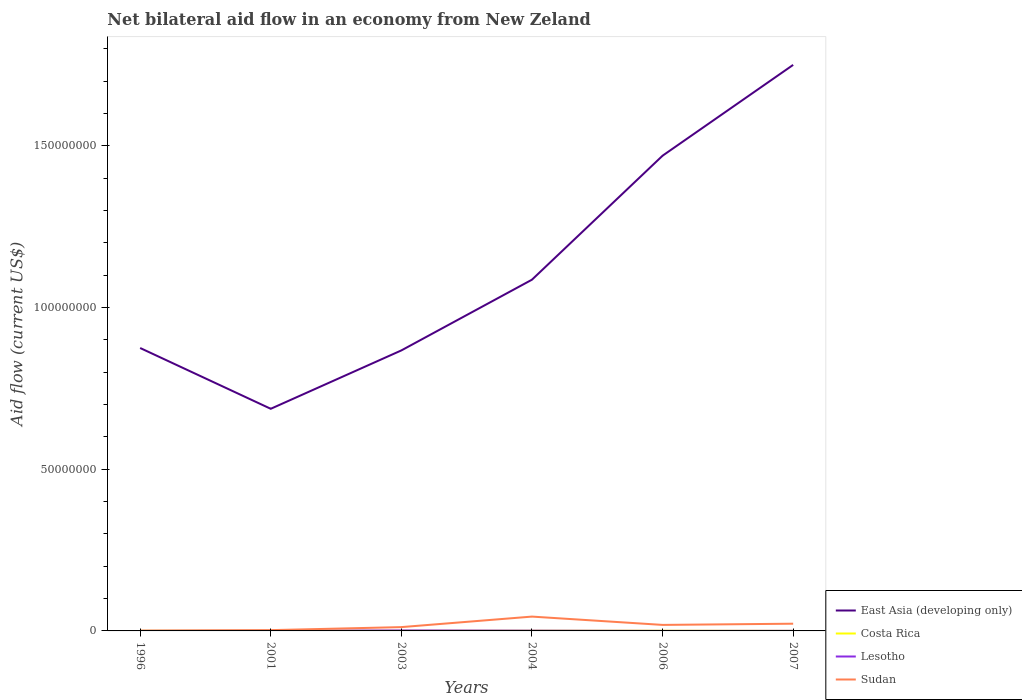Is the number of lines equal to the number of legend labels?
Your answer should be very brief. Yes. In which year was the net bilateral aid flow in East Asia (developing only) maximum?
Provide a short and direct response. 2001. How many years are there in the graph?
Keep it short and to the point. 6. What is the difference between two consecutive major ticks on the Y-axis?
Your response must be concise. 5.00e+07. Does the graph contain any zero values?
Give a very brief answer. No. Does the graph contain grids?
Offer a terse response. No. How are the legend labels stacked?
Your answer should be very brief. Vertical. What is the title of the graph?
Offer a very short reply. Net bilateral aid flow in an economy from New Zeland. Does "Eritrea" appear as one of the legend labels in the graph?
Offer a very short reply. No. What is the label or title of the X-axis?
Give a very brief answer. Years. What is the label or title of the Y-axis?
Your response must be concise. Aid flow (current US$). What is the Aid flow (current US$) of East Asia (developing only) in 1996?
Your answer should be compact. 8.75e+07. What is the Aid flow (current US$) in Costa Rica in 1996?
Your answer should be compact. 4.00e+04. What is the Aid flow (current US$) of Lesotho in 1996?
Ensure brevity in your answer.  10000. What is the Aid flow (current US$) of Sudan in 1996?
Provide a short and direct response. 7.00e+04. What is the Aid flow (current US$) of East Asia (developing only) in 2001?
Ensure brevity in your answer.  6.87e+07. What is the Aid flow (current US$) in Sudan in 2001?
Offer a terse response. 2.40e+05. What is the Aid flow (current US$) in East Asia (developing only) in 2003?
Ensure brevity in your answer.  8.67e+07. What is the Aid flow (current US$) in Lesotho in 2003?
Make the answer very short. 1.50e+05. What is the Aid flow (current US$) of Sudan in 2003?
Offer a very short reply. 1.18e+06. What is the Aid flow (current US$) of East Asia (developing only) in 2004?
Make the answer very short. 1.09e+08. What is the Aid flow (current US$) of Costa Rica in 2004?
Ensure brevity in your answer.  7.00e+04. What is the Aid flow (current US$) in Sudan in 2004?
Your response must be concise. 4.43e+06. What is the Aid flow (current US$) in East Asia (developing only) in 2006?
Keep it short and to the point. 1.47e+08. What is the Aid flow (current US$) in Lesotho in 2006?
Provide a succinct answer. 10000. What is the Aid flow (current US$) of Sudan in 2006?
Make the answer very short. 1.86e+06. What is the Aid flow (current US$) of East Asia (developing only) in 2007?
Keep it short and to the point. 1.75e+08. What is the Aid flow (current US$) in Costa Rica in 2007?
Keep it short and to the point. 2.00e+04. What is the Aid flow (current US$) in Sudan in 2007?
Your response must be concise. 2.23e+06. Across all years, what is the maximum Aid flow (current US$) of East Asia (developing only)?
Ensure brevity in your answer.  1.75e+08. Across all years, what is the maximum Aid flow (current US$) in Sudan?
Your response must be concise. 4.43e+06. Across all years, what is the minimum Aid flow (current US$) in East Asia (developing only)?
Your answer should be very brief. 6.87e+07. Across all years, what is the minimum Aid flow (current US$) in Costa Rica?
Keep it short and to the point. 2.00e+04. Across all years, what is the minimum Aid flow (current US$) of Lesotho?
Give a very brief answer. 10000. What is the total Aid flow (current US$) in East Asia (developing only) in the graph?
Your answer should be compact. 6.74e+08. What is the total Aid flow (current US$) of Costa Rica in the graph?
Your answer should be compact. 3.00e+05. What is the total Aid flow (current US$) in Sudan in the graph?
Your response must be concise. 1.00e+07. What is the difference between the Aid flow (current US$) in East Asia (developing only) in 1996 and that in 2001?
Offer a terse response. 1.88e+07. What is the difference between the Aid flow (current US$) of Lesotho in 1996 and that in 2001?
Offer a very short reply. -4.00e+04. What is the difference between the Aid flow (current US$) in East Asia (developing only) in 1996 and that in 2003?
Your response must be concise. 7.50e+05. What is the difference between the Aid flow (current US$) of Sudan in 1996 and that in 2003?
Offer a very short reply. -1.11e+06. What is the difference between the Aid flow (current US$) of East Asia (developing only) in 1996 and that in 2004?
Ensure brevity in your answer.  -2.11e+07. What is the difference between the Aid flow (current US$) in Lesotho in 1996 and that in 2004?
Make the answer very short. -7.00e+04. What is the difference between the Aid flow (current US$) of Sudan in 1996 and that in 2004?
Your response must be concise. -4.36e+06. What is the difference between the Aid flow (current US$) of East Asia (developing only) in 1996 and that in 2006?
Your response must be concise. -5.95e+07. What is the difference between the Aid flow (current US$) in Costa Rica in 1996 and that in 2006?
Provide a short and direct response. -2.00e+04. What is the difference between the Aid flow (current US$) of Sudan in 1996 and that in 2006?
Your response must be concise. -1.79e+06. What is the difference between the Aid flow (current US$) of East Asia (developing only) in 1996 and that in 2007?
Offer a very short reply. -8.76e+07. What is the difference between the Aid flow (current US$) in Costa Rica in 1996 and that in 2007?
Offer a very short reply. 2.00e+04. What is the difference between the Aid flow (current US$) in Sudan in 1996 and that in 2007?
Your response must be concise. -2.16e+06. What is the difference between the Aid flow (current US$) in East Asia (developing only) in 2001 and that in 2003?
Give a very brief answer. -1.80e+07. What is the difference between the Aid flow (current US$) of Costa Rica in 2001 and that in 2003?
Make the answer very short. -10000. What is the difference between the Aid flow (current US$) of Lesotho in 2001 and that in 2003?
Ensure brevity in your answer.  -1.00e+05. What is the difference between the Aid flow (current US$) of Sudan in 2001 and that in 2003?
Your answer should be very brief. -9.40e+05. What is the difference between the Aid flow (current US$) of East Asia (developing only) in 2001 and that in 2004?
Your answer should be very brief. -3.99e+07. What is the difference between the Aid flow (current US$) in Costa Rica in 2001 and that in 2004?
Keep it short and to the point. -2.00e+04. What is the difference between the Aid flow (current US$) in Sudan in 2001 and that in 2004?
Ensure brevity in your answer.  -4.19e+06. What is the difference between the Aid flow (current US$) in East Asia (developing only) in 2001 and that in 2006?
Make the answer very short. -7.83e+07. What is the difference between the Aid flow (current US$) in Costa Rica in 2001 and that in 2006?
Give a very brief answer. -10000. What is the difference between the Aid flow (current US$) of Sudan in 2001 and that in 2006?
Ensure brevity in your answer.  -1.62e+06. What is the difference between the Aid flow (current US$) of East Asia (developing only) in 2001 and that in 2007?
Your answer should be very brief. -1.06e+08. What is the difference between the Aid flow (current US$) of Lesotho in 2001 and that in 2007?
Your response must be concise. 2.00e+04. What is the difference between the Aid flow (current US$) in Sudan in 2001 and that in 2007?
Your answer should be very brief. -1.99e+06. What is the difference between the Aid flow (current US$) in East Asia (developing only) in 2003 and that in 2004?
Your response must be concise. -2.19e+07. What is the difference between the Aid flow (current US$) of Costa Rica in 2003 and that in 2004?
Provide a succinct answer. -10000. What is the difference between the Aid flow (current US$) of Sudan in 2003 and that in 2004?
Your answer should be very brief. -3.25e+06. What is the difference between the Aid flow (current US$) in East Asia (developing only) in 2003 and that in 2006?
Your answer should be very brief. -6.02e+07. What is the difference between the Aid flow (current US$) of Lesotho in 2003 and that in 2006?
Provide a succinct answer. 1.40e+05. What is the difference between the Aid flow (current US$) in Sudan in 2003 and that in 2006?
Your answer should be very brief. -6.80e+05. What is the difference between the Aid flow (current US$) in East Asia (developing only) in 2003 and that in 2007?
Your answer should be very brief. -8.83e+07. What is the difference between the Aid flow (current US$) of Sudan in 2003 and that in 2007?
Ensure brevity in your answer.  -1.05e+06. What is the difference between the Aid flow (current US$) of East Asia (developing only) in 2004 and that in 2006?
Your answer should be compact. -3.83e+07. What is the difference between the Aid flow (current US$) in Costa Rica in 2004 and that in 2006?
Your answer should be very brief. 10000. What is the difference between the Aid flow (current US$) in Lesotho in 2004 and that in 2006?
Your answer should be very brief. 7.00e+04. What is the difference between the Aid flow (current US$) of Sudan in 2004 and that in 2006?
Ensure brevity in your answer.  2.57e+06. What is the difference between the Aid flow (current US$) of East Asia (developing only) in 2004 and that in 2007?
Give a very brief answer. -6.64e+07. What is the difference between the Aid flow (current US$) of Costa Rica in 2004 and that in 2007?
Offer a terse response. 5.00e+04. What is the difference between the Aid flow (current US$) of Sudan in 2004 and that in 2007?
Your response must be concise. 2.20e+06. What is the difference between the Aid flow (current US$) of East Asia (developing only) in 2006 and that in 2007?
Your answer should be very brief. -2.81e+07. What is the difference between the Aid flow (current US$) of Costa Rica in 2006 and that in 2007?
Your response must be concise. 4.00e+04. What is the difference between the Aid flow (current US$) of Sudan in 2006 and that in 2007?
Give a very brief answer. -3.70e+05. What is the difference between the Aid flow (current US$) in East Asia (developing only) in 1996 and the Aid flow (current US$) in Costa Rica in 2001?
Offer a terse response. 8.74e+07. What is the difference between the Aid flow (current US$) in East Asia (developing only) in 1996 and the Aid flow (current US$) in Lesotho in 2001?
Provide a succinct answer. 8.74e+07. What is the difference between the Aid flow (current US$) in East Asia (developing only) in 1996 and the Aid flow (current US$) in Sudan in 2001?
Your answer should be compact. 8.72e+07. What is the difference between the Aid flow (current US$) of Costa Rica in 1996 and the Aid flow (current US$) of Lesotho in 2001?
Provide a short and direct response. -10000. What is the difference between the Aid flow (current US$) in Lesotho in 1996 and the Aid flow (current US$) in Sudan in 2001?
Ensure brevity in your answer.  -2.30e+05. What is the difference between the Aid flow (current US$) in East Asia (developing only) in 1996 and the Aid flow (current US$) in Costa Rica in 2003?
Your answer should be very brief. 8.74e+07. What is the difference between the Aid flow (current US$) in East Asia (developing only) in 1996 and the Aid flow (current US$) in Lesotho in 2003?
Your answer should be very brief. 8.73e+07. What is the difference between the Aid flow (current US$) of East Asia (developing only) in 1996 and the Aid flow (current US$) of Sudan in 2003?
Provide a succinct answer. 8.63e+07. What is the difference between the Aid flow (current US$) in Costa Rica in 1996 and the Aid flow (current US$) in Sudan in 2003?
Give a very brief answer. -1.14e+06. What is the difference between the Aid flow (current US$) in Lesotho in 1996 and the Aid flow (current US$) in Sudan in 2003?
Offer a terse response. -1.17e+06. What is the difference between the Aid flow (current US$) in East Asia (developing only) in 1996 and the Aid flow (current US$) in Costa Rica in 2004?
Your answer should be very brief. 8.74e+07. What is the difference between the Aid flow (current US$) in East Asia (developing only) in 1996 and the Aid flow (current US$) in Lesotho in 2004?
Your response must be concise. 8.74e+07. What is the difference between the Aid flow (current US$) in East Asia (developing only) in 1996 and the Aid flow (current US$) in Sudan in 2004?
Your response must be concise. 8.31e+07. What is the difference between the Aid flow (current US$) of Costa Rica in 1996 and the Aid flow (current US$) of Sudan in 2004?
Your response must be concise. -4.39e+06. What is the difference between the Aid flow (current US$) of Lesotho in 1996 and the Aid flow (current US$) of Sudan in 2004?
Provide a short and direct response. -4.42e+06. What is the difference between the Aid flow (current US$) in East Asia (developing only) in 1996 and the Aid flow (current US$) in Costa Rica in 2006?
Offer a terse response. 8.74e+07. What is the difference between the Aid flow (current US$) in East Asia (developing only) in 1996 and the Aid flow (current US$) in Lesotho in 2006?
Keep it short and to the point. 8.75e+07. What is the difference between the Aid flow (current US$) of East Asia (developing only) in 1996 and the Aid flow (current US$) of Sudan in 2006?
Offer a terse response. 8.56e+07. What is the difference between the Aid flow (current US$) of Costa Rica in 1996 and the Aid flow (current US$) of Lesotho in 2006?
Offer a very short reply. 3.00e+04. What is the difference between the Aid flow (current US$) of Costa Rica in 1996 and the Aid flow (current US$) of Sudan in 2006?
Your answer should be compact. -1.82e+06. What is the difference between the Aid flow (current US$) in Lesotho in 1996 and the Aid flow (current US$) in Sudan in 2006?
Make the answer very short. -1.85e+06. What is the difference between the Aid flow (current US$) of East Asia (developing only) in 1996 and the Aid flow (current US$) of Costa Rica in 2007?
Provide a succinct answer. 8.75e+07. What is the difference between the Aid flow (current US$) of East Asia (developing only) in 1996 and the Aid flow (current US$) of Lesotho in 2007?
Ensure brevity in your answer.  8.75e+07. What is the difference between the Aid flow (current US$) of East Asia (developing only) in 1996 and the Aid flow (current US$) of Sudan in 2007?
Your answer should be very brief. 8.53e+07. What is the difference between the Aid flow (current US$) of Costa Rica in 1996 and the Aid flow (current US$) of Sudan in 2007?
Ensure brevity in your answer.  -2.19e+06. What is the difference between the Aid flow (current US$) of Lesotho in 1996 and the Aid flow (current US$) of Sudan in 2007?
Provide a succinct answer. -2.22e+06. What is the difference between the Aid flow (current US$) of East Asia (developing only) in 2001 and the Aid flow (current US$) of Costa Rica in 2003?
Your answer should be compact. 6.86e+07. What is the difference between the Aid flow (current US$) in East Asia (developing only) in 2001 and the Aid flow (current US$) in Lesotho in 2003?
Give a very brief answer. 6.85e+07. What is the difference between the Aid flow (current US$) of East Asia (developing only) in 2001 and the Aid flow (current US$) of Sudan in 2003?
Make the answer very short. 6.75e+07. What is the difference between the Aid flow (current US$) in Costa Rica in 2001 and the Aid flow (current US$) in Lesotho in 2003?
Make the answer very short. -1.00e+05. What is the difference between the Aid flow (current US$) in Costa Rica in 2001 and the Aid flow (current US$) in Sudan in 2003?
Offer a terse response. -1.13e+06. What is the difference between the Aid flow (current US$) in Lesotho in 2001 and the Aid flow (current US$) in Sudan in 2003?
Provide a succinct answer. -1.13e+06. What is the difference between the Aid flow (current US$) in East Asia (developing only) in 2001 and the Aid flow (current US$) in Costa Rica in 2004?
Give a very brief answer. 6.86e+07. What is the difference between the Aid flow (current US$) of East Asia (developing only) in 2001 and the Aid flow (current US$) of Lesotho in 2004?
Make the answer very short. 6.86e+07. What is the difference between the Aid flow (current US$) of East Asia (developing only) in 2001 and the Aid flow (current US$) of Sudan in 2004?
Your answer should be compact. 6.43e+07. What is the difference between the Aid flow (current US$) of Costa Rica in 2001 and the Aid flow (current US$) of Lesotho in 2004?
Give a very brief answer. -3.00e+04. What is the difference between the Aid flow (current US$) of Costa Rica in 2001 and the Aid flow (current US$) of Sudan in 2004?
Make the answer very short. -4.38e+06. What is the difference between the Aid flow (current US$) of Lesotho in 2001 and the Aid flow (current US$) of Sudan in 2004?
Your answer should be compact. -4.38e+06. What is the difference between the Aid flow (current US$) of East Asia (developing only) in 2001 and the Aid flow (current US$) of Costa Rica in 2006?
Offer a terse response. 6.86e+07. What is the difference between the Aid flow (current US$) of East Asia (developing only) in 2001 and the Aid flow (current US$) of Lesotho in 2006?
Offer a very short reply. 6.87e+07. What is the difference between the Aid flow (current US$) in East Asia (developing only) in 2001 and the Aid flow (current US$) in Sudan in 2006?
Your answer should be compact. 6.68e+07. What is the difference between the Aid flow (current US$) of Costa Rica in 2001 and the Aid flow (current US$) of Lesotho in 2006?
Make the answer very short. 4.00e+04. What is the difference between the Aid flow (current US$) of Costa Rica in 2001 and the Aid flow (current US$) of Sudan in 2006?
Provide a short and direct response. -1.81e+06. What is the difference between the Aid flow (current US$) of Lesotho in 2001 and the Aid flow (current US$) of Sudan in 2006?
Give a very brief answer. -1.81e+06. What is the difference between the Aid flow (current US$) of East Asia (developing only) in 2001 and the Aid flow (current US$) of Costa Rica in 2007?
Make the answer very short. 6.87e+07. What is the difference between the Aid flow (current US$) in East Asia (developing only) in 2001 and the Aid flow (current US$) in Lesotho in 2007?
Your answer should be compact. 6.87e+07. What is the difference between the Aid flow (current US$) in East Asia (developing only) in 2001 and the Aid flow (current US$) in Sudan in 2007?
Provide a succinct answer. 6.65e+07. What is the difference between the Aid flow (current US$) in Costa Rica in 2001 and the Aid flow (current US$) in Sudan in 2007?
Your answer should be very brief. -2.18e+06. What is the difference between the Aid flow (current US$) in Lesotho in 2001 and the Aid flow (current US$) in Sudan in 2007?
Your answer should be very brief. -2.18e+06. What is the difference between the Aid flow (current US$) in East Asia (developing only) in 2003 and the Aid flow (current US$) in Costa Rica in 2004?
Your response must be concise. 8.67e+07. What is the difference between the Aid flow (current US$) in East Asia (developing only) in 2003 and the Aid flow (current US$) in Lesotho in 2004?
Make the answer very short. 8.67e+07. What is the difference between the Aid flow (current US$) in East Asia (developing only) in 2003 and the Aid flow (current US$) in Sudan in 2004?
Provide a short and direct response. 8.23e+07. What is the difference between the Aid flow (current US$) in Costa Rica in 2003 and the Aid flow (current US$) in Sudan in 2004?
Give a very brief answer. -4.37e+06. What is the difference between the Aid flow (current US$) in Lesotho in 2003 and the Aid flow (current US$) in Sudan in 2004?
Keep it short and to the point. -4.28e+06. What is the difference between the Aid flow (current US$) in East Asia (developing only) in 2003 and the Aid flow (current US$) in Costa Rica in 2006?
Offer a terse response. 8.67e+07. What is the difference between the Aid flow (current US$) in East Asia (developing only) in 2003 and the Aid flow (current US$) in Lesotho in 2006?
Provide a succinct answer. 8.67e+07. What is the difference between the Aid flow (current US$) in East Asia (developing only) in 2003 and the Aid flow (current US$) in Sudan in 2006?
Provide a short and direct response. 8.49e+07. What is the difference between the Aid flow (current US$) of Costa Rica in 2003 and the Aid flow (current US$) of Sudan in 2006?
Give a very brief answer. -1.80e+06. What is the difference between the Aid flow (current US$) of Lesotho in 2003 and the Aid flow (current US$) of Sudan in 2006?
Your answer should be compact. -1.71e+06. What is the difference between the Aid flow (current US$) in East Asia (developing only) in 2003 and the Aid flow (current US$) in Costa Rica in 2007?
Ensure brevity in your answer.  8.67e+07. What is the difference between the Aid flow (current US$) of East Asia (developing only) in 2003 and the Aid flow (current US$) of Lesotho in 2007?
Provide a short and direct response. 8.67e+07. What is the difference between the Aid flow (current US$) in East Asia (developing only) in 2003 and the Aid flow (current US$) in Sudan in 2007?
Provide a succinct answer. 8.45e+07. What is the difference between the Aid flow (current US$) of Costa Rica in 2003 and the Aid flow (current US$) of Sudan in 2007?
Your answer should be very brief. -2.17e+06. What is the difference between the Aid flow (current US$) of Lesotho in 2003 and the Aid flow (current US$) of Sudan in 2007?
Your answer should be compact. -2.08e+06. What is the difference between the Aid flow (current US$) in East Asia (developing only) in 2004 and the Aid flow (current US$) in Costa Rica in 2006?
Provide a short and direct response. 1.09e+08. What is the difference between the Aid flow (current US$) in East Asia (developing only) in 2004 and the Aid flow (current US$) in Lesotho in 2006?
Offer a terse response. 1.09e+08. What is the difference between the Aid flow (current US$) in East Asia (developing only) in 2004 and the Aid flow (current US$) in Sudan in 2006?
Ensure brevity in your answer.  1.07e+08. What is the difference between the Aid flow (current US$) of Costa Rica in 2004 and the Aid flow (current US$) of Lesotho in 2006?
Your answer should be very brief. 6.00e+04. What is the difference between the Aid flow (current US$) of Costa Rica in 2004 and the Aid flow (current US$) of Sudan in 2006?
Your answer should be compact. -1.79e+06. What is the difference between the Aid flow (current US$) in Lesotho in 2004 and the Aid flow (current US$) in Sudan in 2006?
Your answer should be compact. -1.78e+06. What is the difference between the Aid flow (current US$) in East Asia (developing only) in 2004 and the Aid flow (current US$) in Costa Rica in 2007?
Give a very brief answer. 1.09e+08. What is the difference between the Aid flow (current US$) in East Asia (developing only) in 2004 and the Aid flow (current US$) in Lesotho in 2007?
Your answer should be compact. 1.09e+08. What is the difference between the Aid flow (current US$) in East Asia (developing only) in 2004 and the Aid flow (current US$) in Sudan in 2007?
Provide a short and direct response. 1.06e+08. What is the difference between the Aid flow (current US$) in Costa Rica in 2004 and the Aid flow (current US$) in Lesotho in 2007?
Your response must be concise. 4.00e+04. What is the difference between the Aid flow (current US$) of Costa Rica in 2004 and the Aid flow (current US$) of Sudan in 2007?
Give a very brief answer. -2.16e+06. What is the difference between the Aid flow (current US$) of Lesotho in 2004 and the Aid flow (current US$) of Sudan in 2007?
Your answer should be compact. -2.15e+06. What is the difference between the Aid flow (current US$) in East Asia (developing only) in 2006 and the Aid flow (current US$) in Costa Rica in 2007?
Your answer should be very brief. 1.47e+08. What is the difference between the Aid flow (current US$) of East Asia (developing only) in 2006 and the Aid flow (current US$) of Lesotho in 2007?
Your answer should be compact. 1.47e+08. What is the difference between the Aid flow (current US$) in East Asia (developing only) in 2006 and the Aid flow (current US$) in Sudan in 2007?
Keep it short and to the point. 1.45e+08. What is the difference between the Aid flow (current US$) in Costa Rica in 2006 and the Aid flow (current US$) in Sudan in 2007?
Provide a short and direct response. -2.17e+06. What is the difference between the Aid flow (current US$) in Lesotho in 2006 and the Aid flow (current US$) in Sudan in 2007?
Provide a succinct answer. -2.22e+06. What is the average Aid flow (current US$) of East Asia (developing only) per year?
Your response must be concise. 1.12e+08. What is the average Aid flow (current US$) of Costa Rica per year?
Offer a terse response. 5.00e+04. What is the average Aid flow (current US$) in Lesotho per year?
Your answer should be very brief. 5.50e+04. What is the average Aid flow (current US$) of Sudan per year?
Your answer should be very brief. 1.67e+06. In the year 1996, what is the difference between the Aid flow (current US$) of East Asia (developing only) and Aid flow (current US$) of Costa Rica?
Make the answer very short. 8.74e+07. In the year 1996, what is the difference between the Aid flow (current US$) of East Asia (developing only) and Aid flow (current US$) of Lesotho?
Offer a terse response. 8.75e+07. In the year 1996, what is the difference between the Aid flow (current US$) of East Asia (developing only) and Aid flow (current US$) of Sudan?
Ensure brevity in your answer.  8.74e+07. In the year 2001, what is the difference between the Aid flow (current US$) of East Asia (developing only) and Aid flow (current US$) of Costa Rica?
Your answer should be compact. 6.86e+07. In the year 2001, what is the difference between the Aid flow (current US$) in East Asia (developing only) and Aid flow (current US$) in Lesotho?
Give a very brief answer. 6.86e+07. In the year 2001, what is the difference between the Aid flow (current US$) in East Asia (developing only) and Aid flow (current US$) in Sudan?
Offer a very short reply. 6.84e+07. In the year 2001, what is the difference between the Aid flow (current US$) in Costa Rica and Aid flow (current US$) in Lesotho?
Give a very brief answer. 0. In the year 2001, what is the difference between the Aid flow (current US$) of Lesotho and Aid flow (current US$) of Sudan?
Offer a terse response. -1.90e+05. In the year 2003, what is the difference between the Aid flow (current US$) of East Asia (developing only) and Aid flow (current US$) of Costa Rica?
Ensure brevity in your answer.  8.67e+07. In the year 2003, what is the difference between the Aid flow (current US$) in East Asia (developing only) and Aid flow (current US$) in Lesotho?
Keep it short and to the point. 8.66e+07. In the year 2003, what is the difference between the Aid flow (current US$) of East Asia (developing only) and Aid flow (current US$) of Sudan?
Make the answer very short. 8.56e+07. In the year 2003, what is the difference between the Aid flow (current US$) in Costa Rica and Aid flow (current US$) in Lesotho?
Your answer should be compact. -9.00e+04. In the year 2003, what is the difference between the Aid flow (current US$) in Costa Rica and Aid flow (current US$) in Sudan?
Your answer should be compact. -1.12e+06. In the year 2003, what is the difference between the Aid flow (current US$) of Lesotho and Aid flow (current US$) of Sudan?
Your answer should be very brief. -1.03e+06. In the year 2004, what is the difference between the Aid flow (current US$) in East Asia (developing only) and Aid flow (current US$) in Costa Rica?
Your answer should be compact. 1.09e+08. In the year 2004, what is the difference between the Aid flow (current US$) in East Asia (developing only) and Aid flow (current US$) in Lesotho?
Ensure brevity in your answer.  1.09e+08. In the year 2004, what is the difference between the Aid flow (current US$) in East Asia (developing only) and Aid flow (current US$) in Sudan?
Your response must be concise. 1.04e+08. In the year 2004, what is the difference between the Aid flow (current US$) of Costa Rica and Aid flow (current US$) of Lesotho?
Offer a very short reply. -10000. In the year 2004, what is the difference between the Aid flow (current US$) of Costa Rica and Aid flow (current US$) of Sudan?
Provide a succinct answer. -4.36e+06. In the year 2004, what is the difference between the Aid flow (current US$) of Lesotho and Aid flow (current US$) of Sudan?
Provide a succinct answer. -4.35e+06. In the year 2006, what is the difference between the Aid flow (current US$) of East Asia (developing only) and Aid flow (current US$) of Costa Rica?
Give a very brief answer. 1.47e+08. In the year 2006, what is the difference between the Aid flow (current US$) of East Asia (developing only) and Aid flow (current US$) of Lesotho?
Your answer should be compact. 1.47e+08. In the year 2006, what is the difference between the Aid flow (current US$) in East Asia (developing only) and Aid flow (current US$) in Sudan?
Provide a succinct answer. 1.45e+08. In the year 2006, what is the difference between the Aid flow (current US$) of Costa Rica and Aid flow (current US$) of Lesotho?
Make the answer very short. 5.00e+04. In the year 2006, what is the difference between the Aid flow (current US$) in Costa Rica and Aid flow (current US$) in Sudan?
Provide a short and direct response. -1.80e+06. In the year 2006, what is the difference between the Aid flow (current US$) in Lesotho and Aid flow (current US$) in Sudan?
Make the answer very short. -1.85e+06. In the year 2007, what is the difference between the Aid flow (current US$) of East Asia (developing only) and Aid flow (current US$) of Costa Rica?
Offer a terse response. 1.75e+08. In the year 2007, what is the difference between the Aid flow (current US$) in East Asia (developing only) and Aid flow (current US$) in Lesotho?
Make the answer very short. 1.75e+08. In the year 2007, what is the difference between the Aid flow (current US$) of East Asia (developing only) and Aid flow (current US$) of Sudan?
Your response must be concise. 1.73e+08. In the year 2007, what is the difference between the Aid flow (current US$) of Costa Rica and Aid flow (current US$) of Lesotho?
Offer a terse response. -10000. In the year 2007, what is the difference between the Aid flow (current US$) of Costa Rica and Aid flow (current US$) of Sudan?
Give a very brief answer. -2.21e+06. In the year 2007, what is the difference between the Aid flow (current US$) of Lesotho and Aid flow (current US$) of Sudan?
Make the answer very short. -2.20e+06. What is the ratio of the Aid flow (current US$) of East Asia (developing only) in 1996 to that in 2001?
Your answer should be compact. 1.27. What is the ratio of the Aid flow (current US$) of Lesotho in 1996 to that in 2001?
Provide a short and direct response. 0.2. What is the ratio of the Aid flow (current US$) in Sudan in 1996 to that in 2001?
Offer a very short reply. 0.29. What is the ratio of the Aid flow (current US$) of East Asia (developing only) in 1996 to that in 2003?
Keep it short and to the point. 1.01. What is the ratio of the Aid flow (current US$) of Lesotho in 1996 to that in 2003?
Offer a terse response. 0.07. What is the ratio of the Aid flow (current US$) in Sudan in 1996 to that in 2003?
Offer a very short reply. 0.06. What is the ratio of the Aid flow (current US$) in East Asia (developing only) in 1996 to that in 2004?
Provide a succinct answer. 0.81. What is the ratio of the Aid flow (current US$) in Sudan in 1996 to that in 2004?
Ensure brevity in your answer.  0.02. What is the ratio of the Aid flow (current US$) in East Asia (developing only) in 1996 to that in 2006?
Your response must be concise. 0.6. What is the ratio of the Aid flow (current US$) of Lesotho in 1996 to that in 2006?
Give a very brief answer. 1. What is the ratio of the Aid flow (current US$) in Sudan in 1996 to that in 2006?
Give a very brief answer. 0.04. What is the ratio of the Aid flow (current US$) in East Asia (developing only) in 1996 to that in 2007?
Provide a short and direct response. 0.5. What is the ratio of the Aid flow (current US$) in Costa Rica in 1996 to that in 2007?
Ensure brevity in your answer.  2. What is the ratio of the Aid flow (current US$) in Sudan in 1996 to that in 2007?
Make the answer very short. 0.03. What is the ratio of the Aid flow (current US$) in East Asia (developing only) in 2001 to that in 2003?
Give a very brief answer. 0.79. What is the ratio of the Aid flow (current US$) of Sudan in 2001 to that in 2003?
Provide a short and direct response. 0.2. What is the ratio of the Aid flow (current US$) of East Asia (developing only) in 2001 to that in 2004?
Your answer should be very brief. 0.63. What is the ratio of the Aid flow (current US$) in Costa Rica in 2001 to that in 2004?
Your answer should be compact. 0.71. What is the ratio of the Aid flow (current US$) in Sudan in 2001 to that in 2004?
Your answer should be very brief. 0.05. What is the ratio of the Aid flow (current US$) in East Asia (developing only) in 2001 to that in 2006?
Offer a terse response. 0.47. What is the ratio of the Aid flow (current US$) of Sudan in 2001 to that in 2006?
Provide a succinct answer. 0.13. What is the ratio of the Aid flow (current US$) in East Asia (developing only) in 2001 to that in 2007?
Provide a short and direct response. 0.39. What is the ratio of the Aid flow (current US$) of Sudan in 2001 to that in 2007?
Ensure brevity in your answer.  0.11. What is the ratio of the Aid flow (current US$) of East Asia (developing only) in 2003 to that in 2004?
Give a very brief answer. 0.8. What is the ratio of the Aid flow (current US$) of Lesotho in 2003 to that in 2004?
Your answer should be compact. 1.88. What is the ratio of the Aid flow (current US$) in Sudan in 2003 to that in 2004?
Provide a short and direct response. 0.27. What is the ratio of the Aid flow (current US$) of East Asia (developing only) in 2003 to that in 2006?
Make the answer very short. 0.59. What is the ratio of the Aid flow (current US$) of Sudan in 2003 to that in 2006?
Your response must be concise. 0.63. What is the ratio of the Aid flow (current US$) of East Asia (developing only) in 2003 to that in 2007?
Make the answer very short. 0.5. What is the ratio of the Aid flow (current US$) of Lesotho in 2003 to that in 2007?
Give a very brief answer. 5. What is the ratio of the Aid flow (current US$) of Sudan in 2003 to that in 2007?
Your answer should be very brief. 0.53. What is the ratio of the Aid flow (current US$) in East Asia (developing only) in 2004 to that in 2006?
Provide a short and direct response. 0.74. What is the ratio of the Aid flow (current US$) of Lesotho in 2004 to that in 2006?
Offer a terse response. 8. What is the ratio of the Aid flow (current US$) in Sudan in 2004 to that in 2006?
Provide a succinct answer. 2.38. What is the ratio of the Aid flow (current US$) in East Asia (developing only) in 2004 to that in 2007?
Offer a very short reply. 0.62. What is the ratio of the Aid flow (current US$) in Costa Rica in 2004 to that in 2007?
Offer a terse response. 3.5. What is the ratio of the Aid flow (current US$) in Lesotho in 2004 to that in 2007?
Ensure brevity in your answer.  2.67. What is the ratio of the Aid flow (current US$) in Sudan in 2004 to that in 2007?
Offer a very short reply. 1.99. What is the ratio of the Aid flow (current US$) of East Asia (developing only) in 2006 to that in 2007?
Make the answer very short. 0.84. What is the ratio of the Aid flow (current US$) in Costa Rica in 2006 to that in 2007?
Keep it short and to the point. 3. What is the ratio of the Aid flow (current US$) in Sudan in 2006 to that in 2007?
Give a very brief answer. 0.83. What is the difference between the highest and the second highest Aid flow (current US$) of East Asia (developing only)?
Your answer should be very brief. 2.81e+07. What is the difference between the highest and the second highest Aid flow (current US$) in Sudan?
Your response must be concise. 2.20e+06. What is the difference between the highest and the lowest Aid flow (current US$) in East Asia (developing only)?
Offer a very short reply. 1.06e+08. What is the difference between the highest and the lowest Aid flow (current US$) in Sudan?
Your answer should be compact. 4.36e+06. 